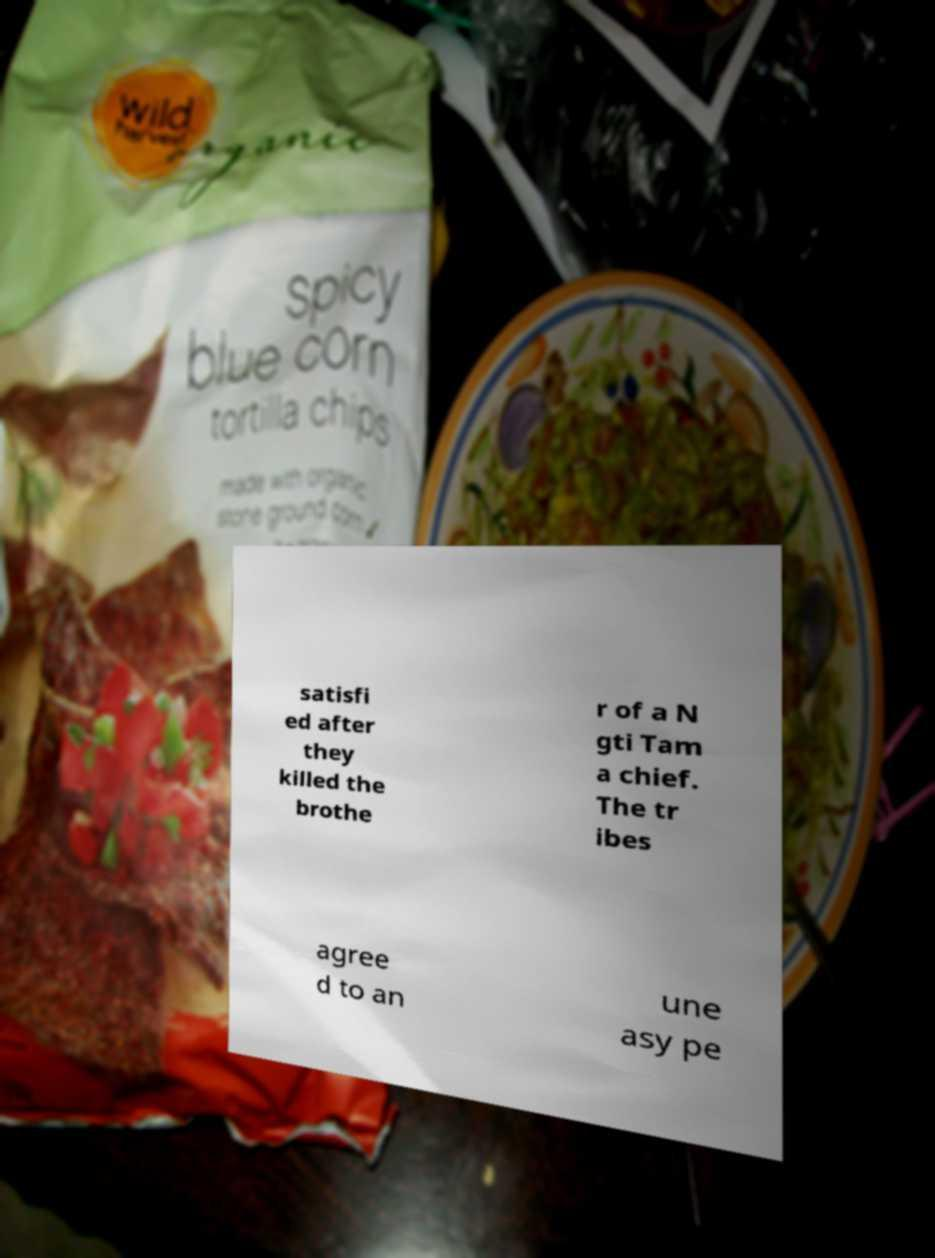What messages or text are displayed in this image? I need them in a readable, typed format. satisfi ed after they killed the brothe r of a N gti Tam a chief. The tr ibes agree d to an une asy pe 